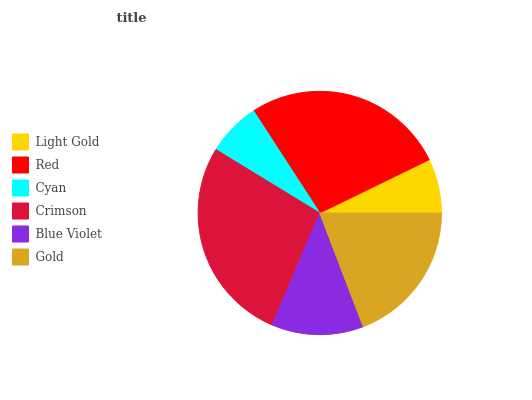Is Cyan the minimum?
Answer yes or no. Yes. Is Crimson the maximum?
Answer yes or no. Yes. Is Red the minimum?
Answer yes or no. No. Is Red the maximum?
Answer yes or no. No. Is Red greater than Light Gold?
Answer yes or no. Yes. Is Light Gold less than Red?
Answer yes or no. Yes. Is Light Gold greater than Red?
Answer yes or no. No. Is Red less than Light Gold?
Answer yes or no. No. Is Gold the high median?
Answer yes or no. Yes. Is Blue Violet the low median?
Answer yes or no. Yes. Is Blue Violet the high median?
Answer yes or no. No. Is Gold the low median?
Answer yes or no. No. 